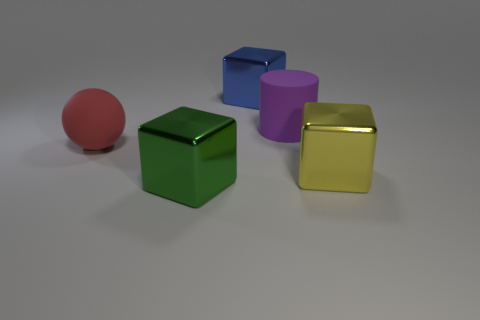Subtract all cyan balls. Subtract all blue cubes. How many balls are left? 1 Add 2 big balls. How many objects exist? 7 Subtract all cylinders. How many objects are left? 4 Add 4 big matte objects. How many big matte objects exist? 6 Subtract 0 blue spheres. How many objects are left? 5 Subtract all brown things. Subtract all large rubber cylinders. How many objects are left? 4 Add 1 matte balls. How many matte balls are left? 2 